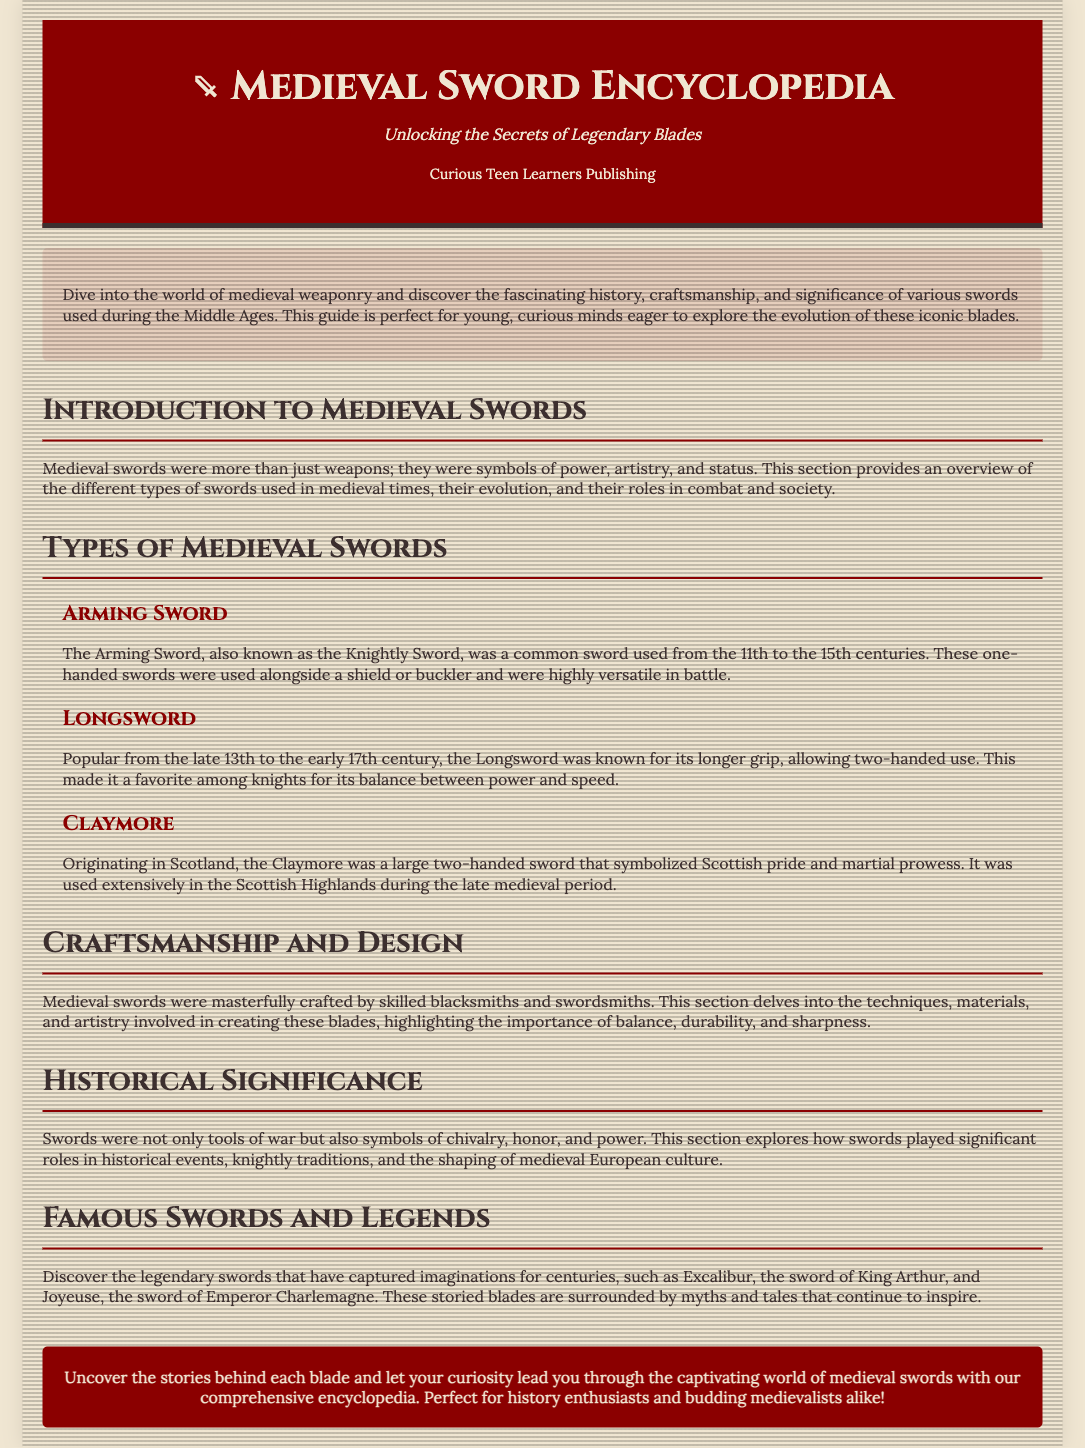What is the title of the encyclopedia? The title is stated in the header of the document.
Answer: Medieval Sword Encyclopedia: A Guide to Historical Blades Who published the encyclopedia? The publisher's name is mentioned in the brand section of the header.
Answer: Curious Teen Learners Publishing What type of sword is referred to as the Knightly Sword? This specific detail is provided under the description of the Arming Sword section.
Answer: Arming Sword What is the origin of the Claymore? The origin of the Claymore is mentioned in the respective subsection.
Answer: Scotland What was the time period of the Longsword's popularity? The time period is clearly defined in the description of the Longsword section.
Answer: Late 13th to early 17th century What is highlighted as a significant aspect of sword craftsmanship? This topic is addressed in the Craftsmanship and Design section, referencing important qualities.
Answer: Balance What legendary sword is associated with King Arthur? This famous sword is mentioned in the Famous Swords and Legends section.
Answer: Excalibur What role did swords play in medieval culture? The significance and role of swords is conveyed in the Historical Significance section.
Answer: Symbols of chivalry What is the subtitle of the encyclopedia? The subtitle is directly noted below the primary title in the header.
Answer: Unlocking the Secrets of Legendary Blades 